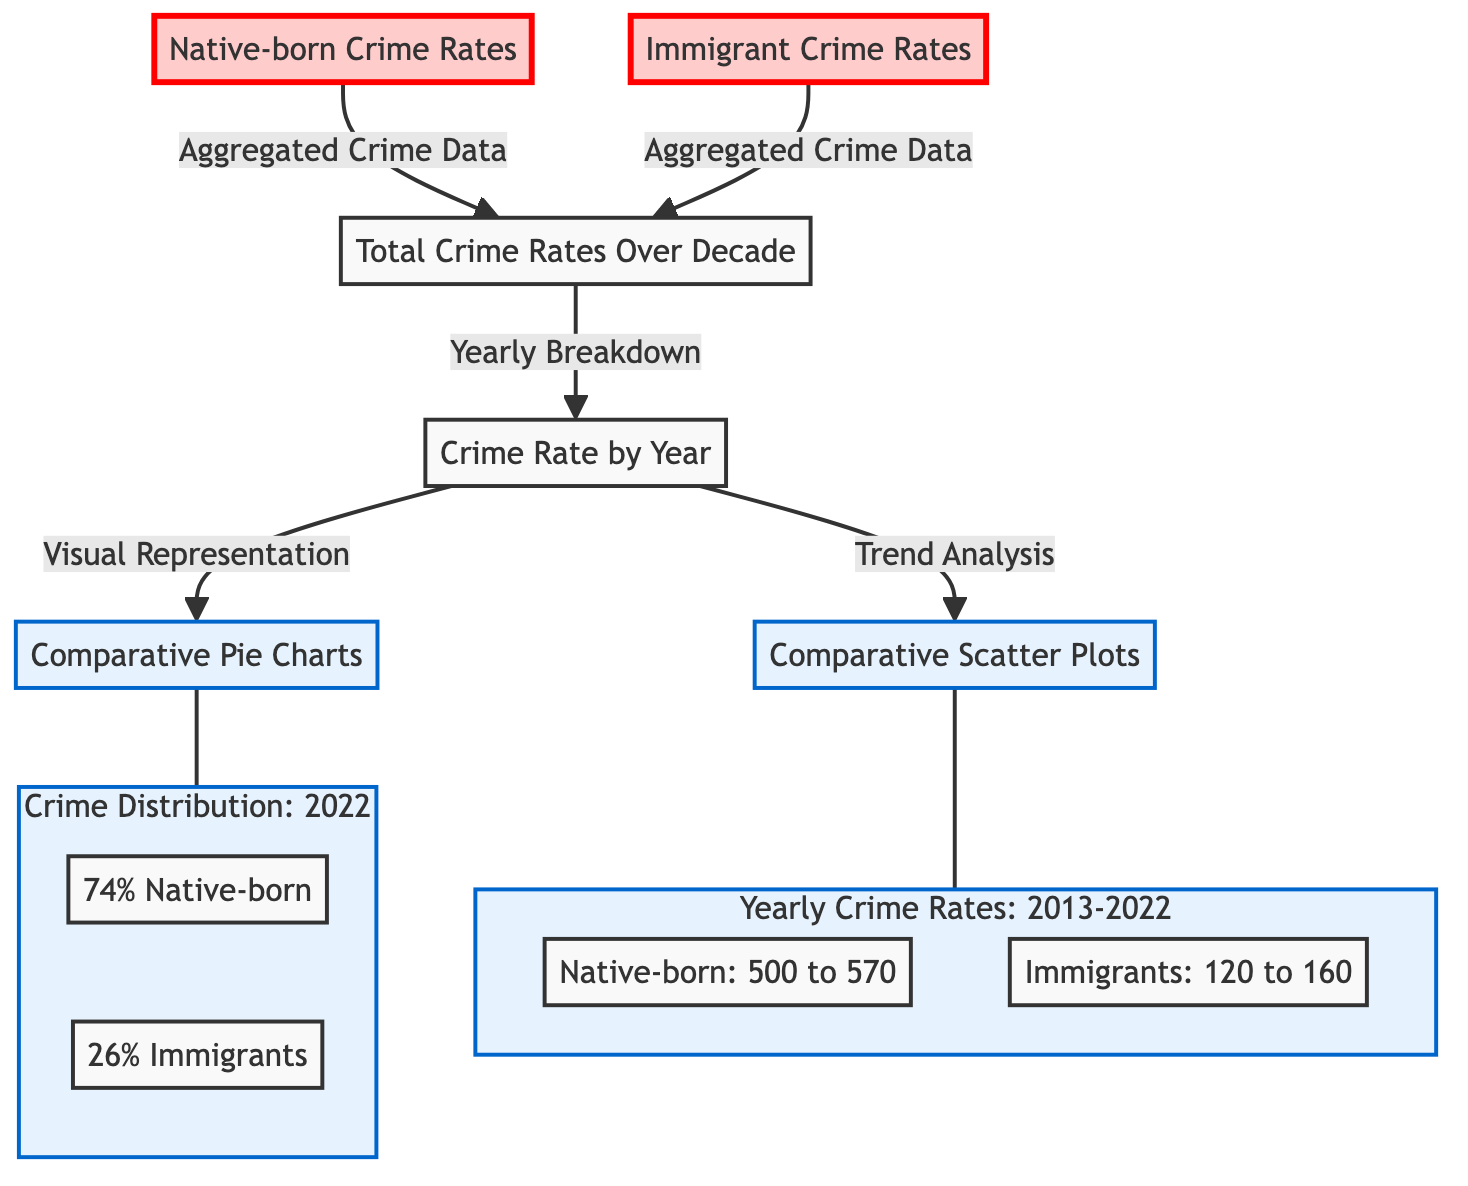What's the percentage of crime rates attributed to native-born citizens in 2022? The pie chart shows the distribution of crime rates in 2022, where 74% is attributed to native-born citizens.
Answer: 74% How many native-born crime rate values are observed in the scatter plot from 2013 to 2022? In the scatter plot, there's a single crime rate value for native-born citizens each year from 2013 to 2022, indicating 10 values total (one for each year).
Answer: 10 What is the highest crime rate recorded for immigrants between 2013 and 2022? Referring to the scatter plot, the highest crime rate recorded for immigrants is 160, which is the maximum value shown on the plot.
Answer: 160 What is the total crime rate range for native-born citizens over the decade? The scatter plot indicates that the crime rates for native-born citizens range from 500 to 570 from 2013 to 2022, giving a clear range.
Answer: 500 to 570 Which type of chart is used to represent crime distribution for the year 2022? The diagram shows that pie charts are utilized to depict the crime distribution specifically for the year 2022, showcasing the proportion of native-born vs. immigrant crime rates.
Answer: Pie Charts What does the 'Yearly Breakdown' node connect to in the diagram? The 'Yearly Breakdown' node connects to two key visual representations: the 'Comparative Pie Charts' and 'Comparative Scatter Plots,' indicating it leads to both types of data visualizations.
Answer: Comparative Pie Charts, Comparative Scatter Plots How many sections are in the pie chart illustrating crime distribution in 2022? The pie chart contains two sections, one for native-born citizens and one for immigrants, representing their respective proportions of crime rates.
Answer: 2 What is the trend observed for immigrant crime rates from 2013 to 2022? Analyzing the data from the scatter plot, the trend shows a gradual increase in immigrant crime rates from 120 to 160, indicating a clear positive trend over the years.
Answer: Gradual increase 